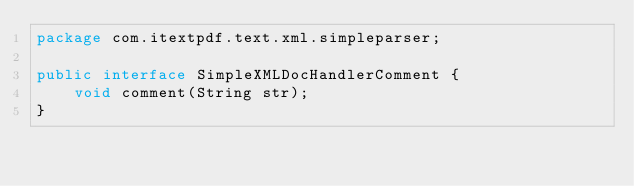Convert code to text. <code><loc_0><loc_0><loc_500><loc_500><_Java_>package com.itextpdf.text.xml.simpleparser;

public interface SimpleXMLDocHandlerComment {
    void comment(String str);
}
</code> 